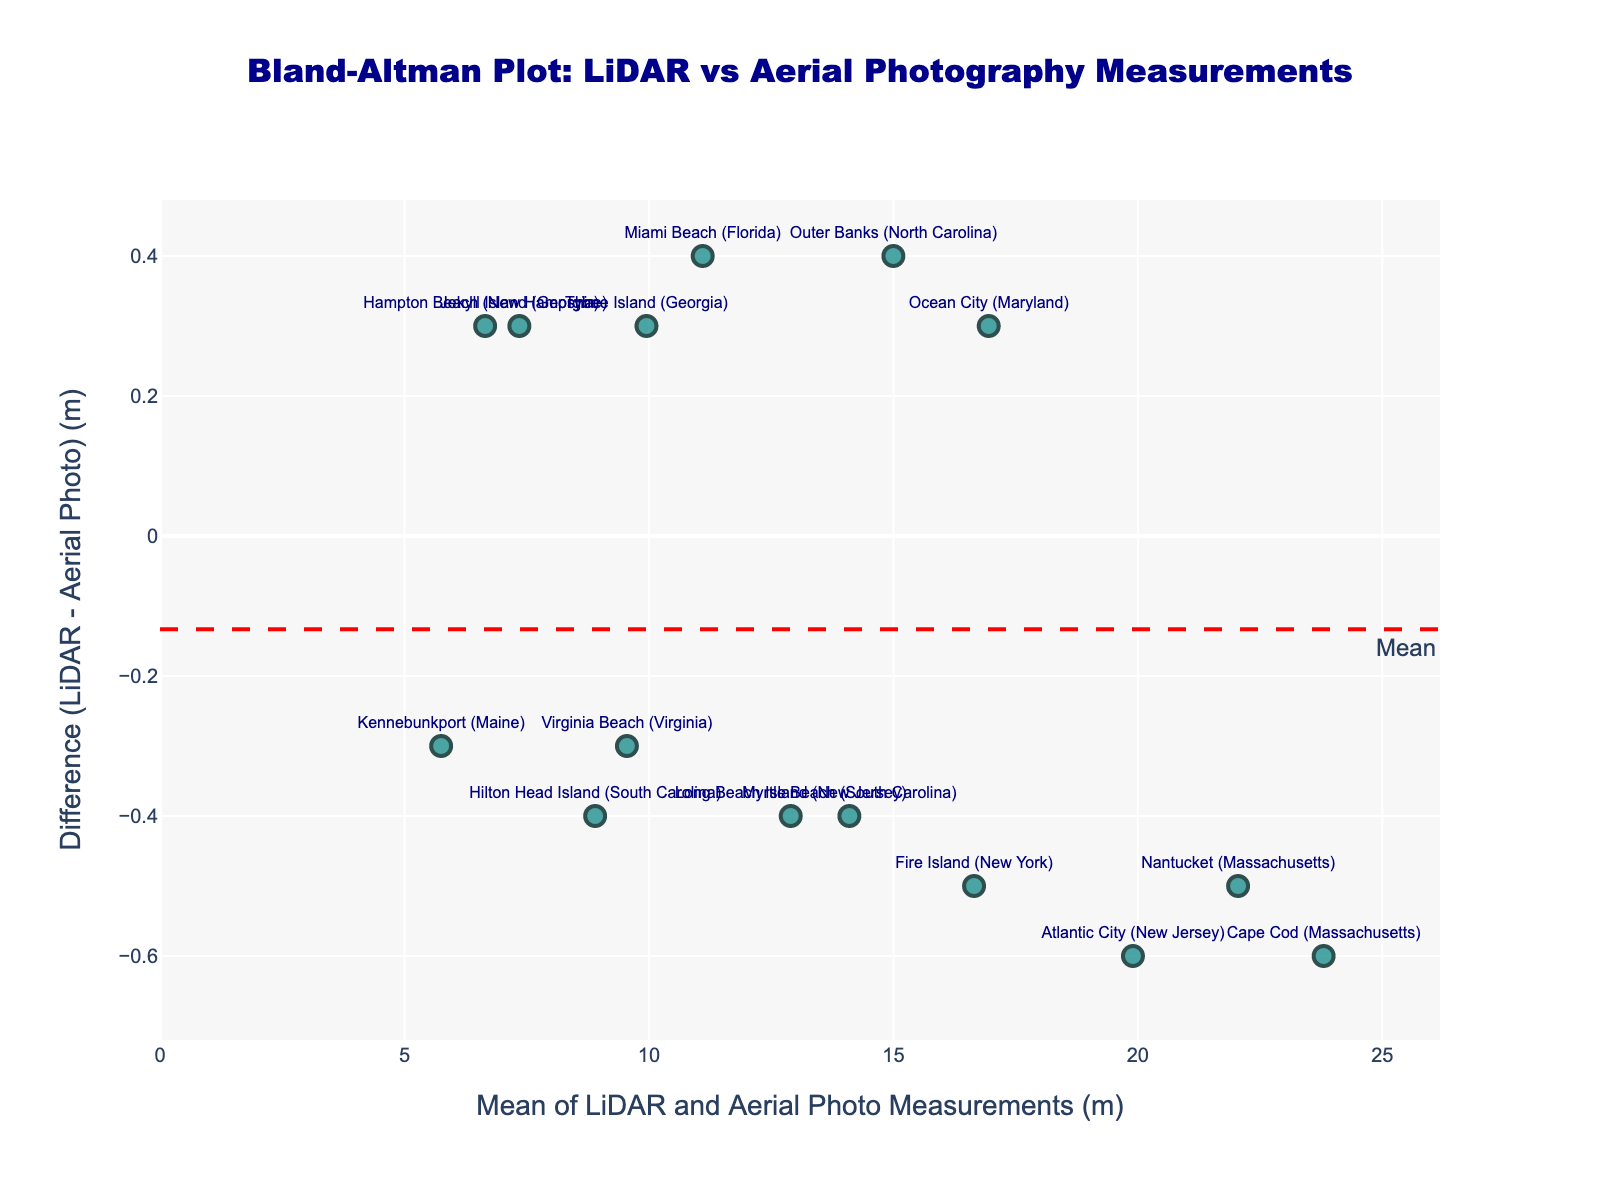what is the title of the plot? The title is usually placed at the top of the plot. In this case, the title is "Bland-Altman Plot: LiDAR vs Aerial Photography Measurements".
Answer: Bland-Altman Plot: LiDAR vs Aerial Photography Measurements what do the x and y axes represent? The x-axis represents the mean of LiDAR and Aerial Photo Measurements (m), and the y-axis represents the Difference (LiDAR - Aerial Photo) (m). This is specified in the axes titles.
Answer: mean of LiDAR and Aerial Photo Measurements (m); Difference (LiDAR - Aerial Photo) (m) how many data points are plotted? Each marker on the plot corresponds to a data point, and we can count the total number of markers. Since there is a marker for each coastline location, we should count 15 data points.
Answer: 15 what do the colored dots represent? The colored dots on the plot represent each measurement's difference and mean for different coastal locations. The color and marker details are specified in the scatter plot setup.
Answer: differences and means for different coastal locations what are the values of the upper and lower limits of agreement? The upper limit of agreement is represented by the horizontal green dotted line labeled "+1.96 SD" and the lower limit of agreement by the green dotted line labeled "-1.96 SD". The positions of these lines indicate the values.
Answer: values above and below -0.06 what is the mean difference? The mean difference is represented by the horizontal red dashed line labeled "Mean". It shows the average difference (LiDAR - Aerial) across all measurements.
Answer: approximately 0.14 m which location has the largest positive difference between LiDAR and aerial photo measurements? The data point with the largest positive value on the y-axis has the largest positive difference. By identifying the highest point along the y-axis and looking at its label, we find that Cape Cod (Massachusetts) shows the largest positive difference.
Answer: Cape Cod (Massachusetts) which location has a mean measurement around 12 meters but has a negative difference? Mean measurements are plotted on the x-axis. We locate the approximate position of 12 meters and find the corresponding label. This location should have a negative y-value (below zero). In this case, it's Long Beach Island (New Jersey).
Answer: Long Beach Island (New Jersey) what is the difference for Outer Banks (North Carolina)? Locate the data point for "Outer Banks (North Carolina)" by its label. The y-axis value corresponding to this label is the difference between the LiDAR and aerial photo measurements.
Answer: 0.4 m which location had very similar measurements according to the plot? Locations with differences close to zero on the y-axis have very similar measurements. The data point nearest to y=0 represents this location. In this case, it's Kennebunkport (Maine).
Answer: Kennebunkport (Maine) 